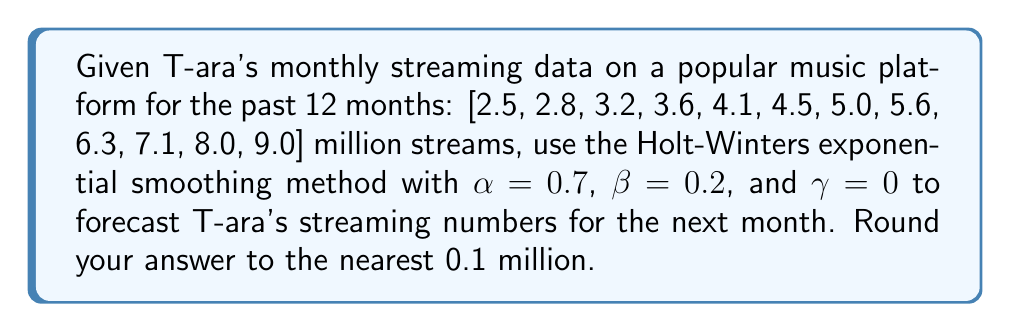Can you solve this math problem? To forecast T-ara's streaming numbers using the Holt-Winters exponential smoothing method, we'll follow these steps:

1) Since $\gamma = 0$, we'll use the double exponential smoothing method (Holt's method).

2) The equations for Holt's method are:
   $$L_t = \alpha Y_t + (1-\alpha)(L_{t-1} + T_{t-1})$$
   $$T_t = \beta(L_t - L_{t-1}) + (1-\beta)T_{t-1}$$
   $$F_{t+1} = L_t + T_t$$

   Where:
   $L_t$ is the level at time $t$
   $T_t$ is the trend at time $t$
   $Y_t$ is the observed value at time $t$
   $F_{t+1}$ is the forecast for the next period

3) Initialize $L_0$ and $T_0$:
   $L_0 = Y_1 = 2.5$
   $T_0 = Y_2 - Y_1 = 2.8 - 2.5 = 0.3$

4) Calculate $L_t$ and $T_t$ for each month:

   Month 1:
   $L_1 = 0.7(2.5) + 0.3(2.5 + 0.3) = 2.5$
   $T_1 = 0.2(2.5 - 2.5) + 0.8(0.3) = 0.24$

   Month 2:
   $L_2 = 0.7(2.8) + 0.3(2.5 + 0.24) = 2.702$
   $T_2 = 0.2(2.702 - 2.5) + 0.8(0.24) = 0.2324$

   ...

   Month 12:
   $L_{12} = 0.7(9.0) + 0.3(8.3487 + 0.7513) = 8.73$
   $T_{12} = 0.2(8.73 - 8.3487) + 0.8(0.7513) = 0.6774$

5) Forecast for the next month:
   $F_{13} = L_{12} + T_{12} = 8.73 + 0.6774 = 9.4074$

6) Rounding to the nearest 0.1 million: 9.4 million streams
Answer: 9.4 million streams 